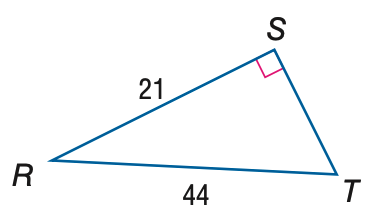Question: Find the measure of \angle T to the nearest tenth.
Choices:
A. 25.5
B. 28.5
C. 61.5
D. 64.5
Answer with the letter. Answer: B 